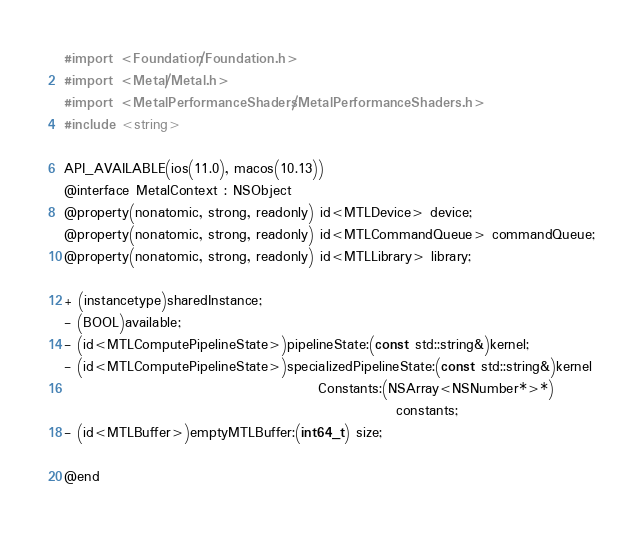<code> <loc_0><loc_0><loc_500><loc_500><_C_>#import <Foundation/Foundation.h>
#import <Metal/Metal.h>
#import <MetalPerformanceShaders/MetalPerformanceShaders.h>
#include <string>

API_AVAILABLE(ios(11.0), macos(10.13))
@interface MetalContext : NSObject
@property(nonatomic, strong, readonly) id<MTLDevice> device;
@property(nonatomic, strong, readonly) id<MTLCommandQueue> commandQueue;
@property(nonatomic, strong, readonly) id<MTLLibrary> library;

+ (instancetype)sharedInstance;
- (BOOL)available;
- (id<MTLComputePipelineState>)pipelineState:(const std::string&)kernel;
- (id<MTLComputePipelineState>)specializedPipelineState:(const std::string&)kernel
                                              Constants:(NSArray<NSNumber*>*)
                                                            constants;
- (id<MTLBuffer>)emptyMTLBuffer:(int64_t) size;

@end
</code> 